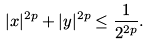<formula> <loc_0><loc_0><loc_500><loc_500>| x | ^ { 2 p } + | y | ^ { 2 p } \leq \frac { 1 } { 2 ^ { 2 p } } .</formula> 